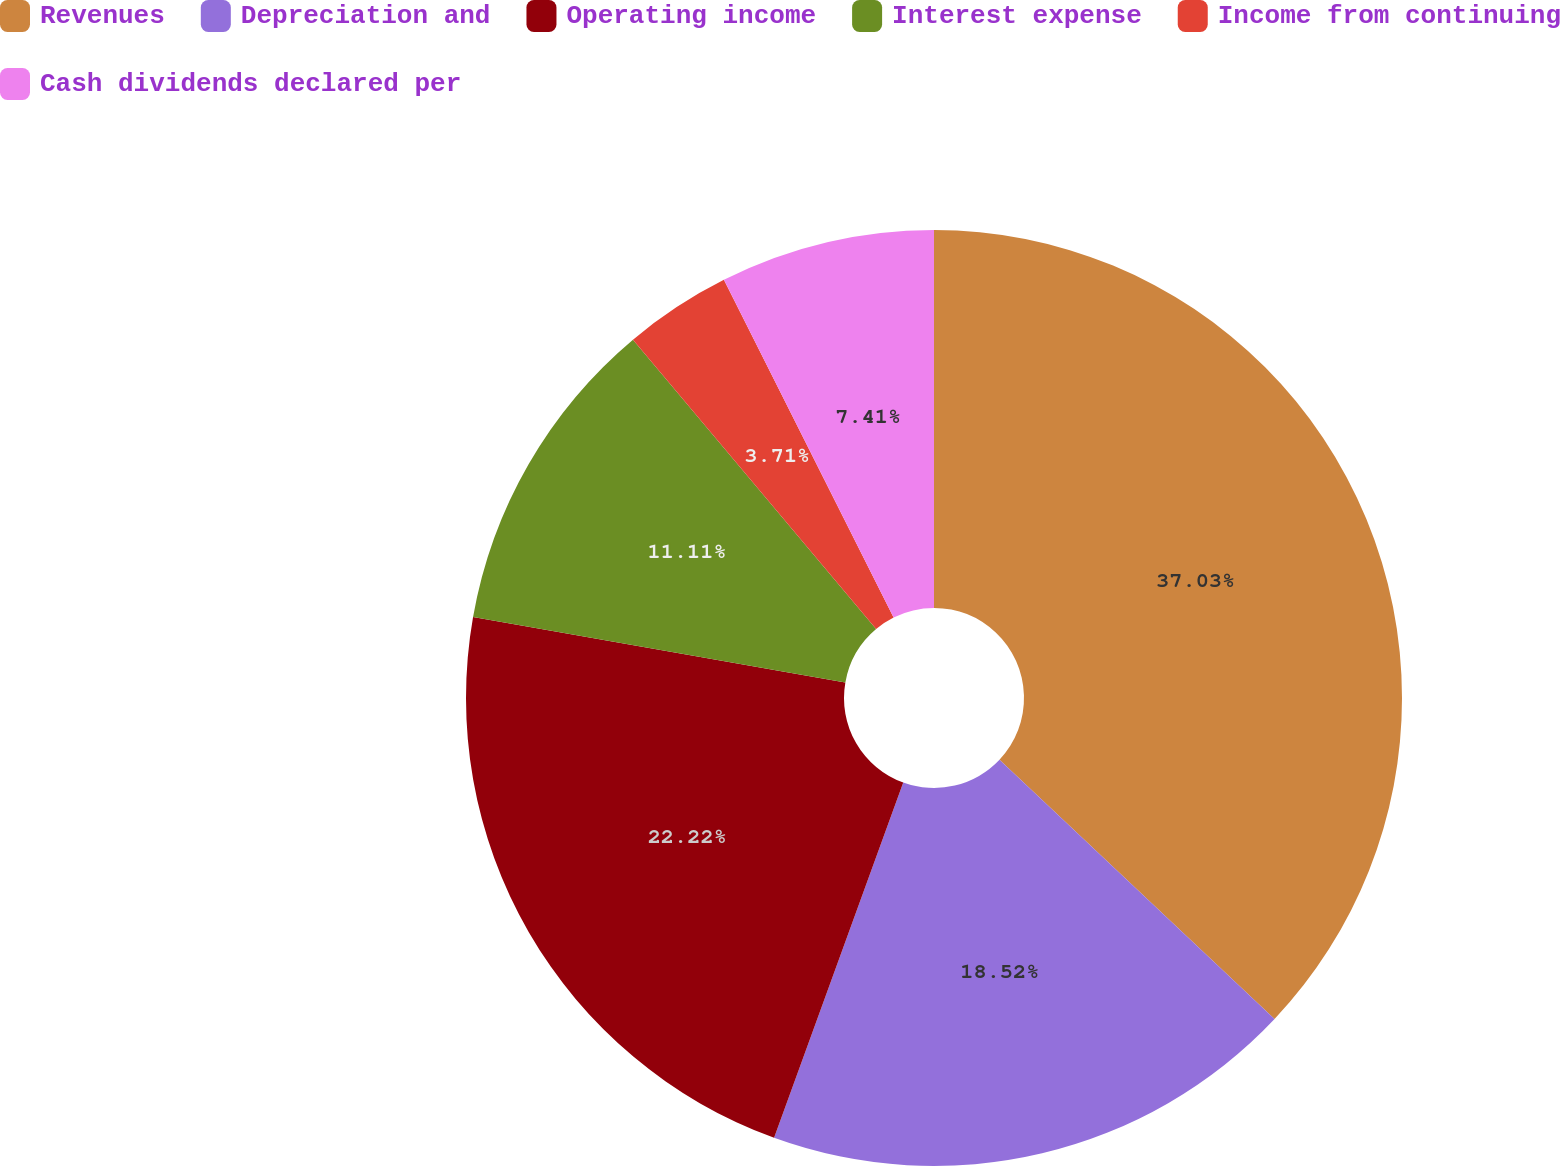Convert chart. <chart><loc_0><loc_0><loc_500><loc_500><pie_chart><fcel>Revenues<fcel>Depreciation and<fcel>Operating income<fcel>Interest expense<fcel>Income from continuing<fcel>Cash dividends declared per<nl><fcel>37.03%<fcel>18.52%<fcel>22.22%<fcel>11.11%<fcel>3.71%<fcel>7.41%<nl></chart> 